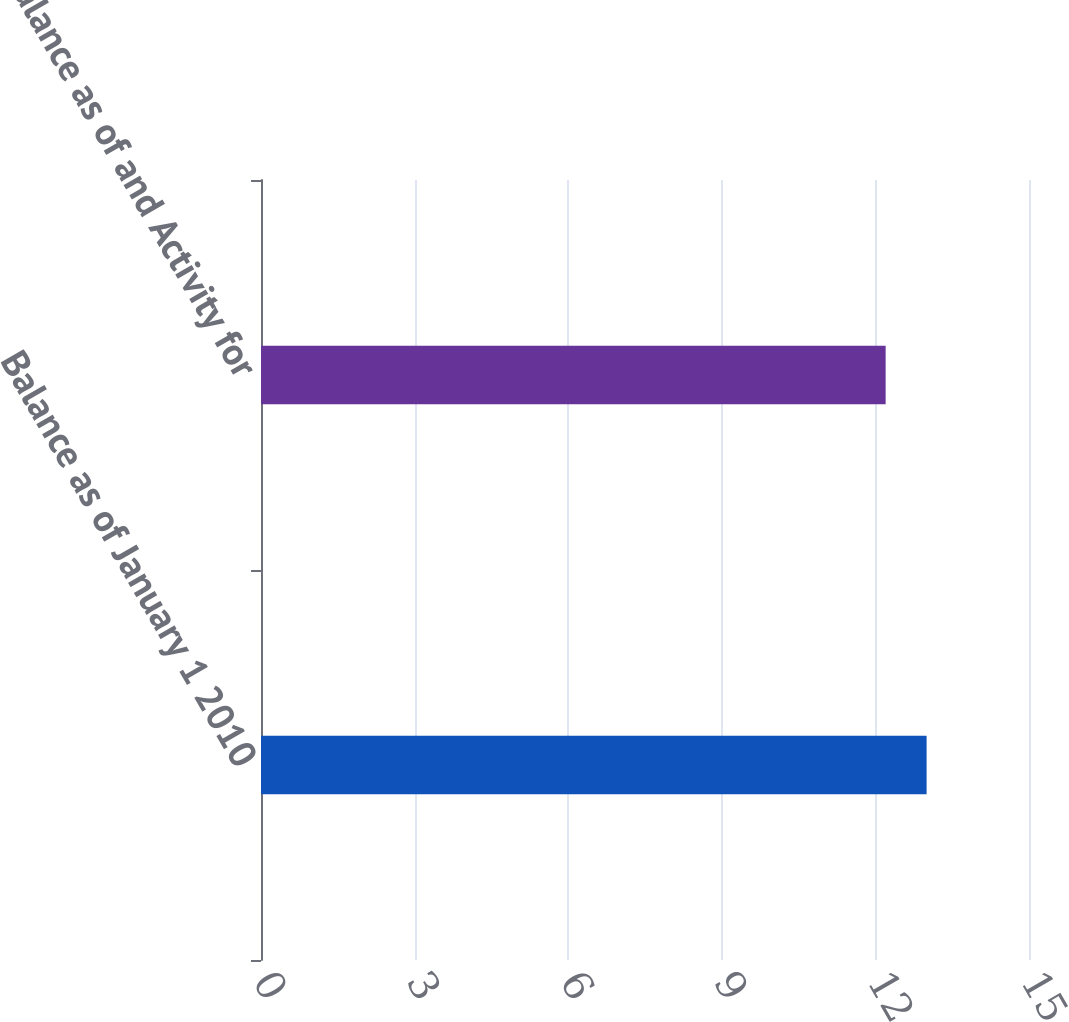Convert chart to OTSL. <chart><loc_0><loc_0><loc_500><loc_500><bar_chart><fcel>Balance as of January 1 2010<fcel>Balance as of and Activity for<nl><fcel>13<fcel>12.2<nl></chart> 